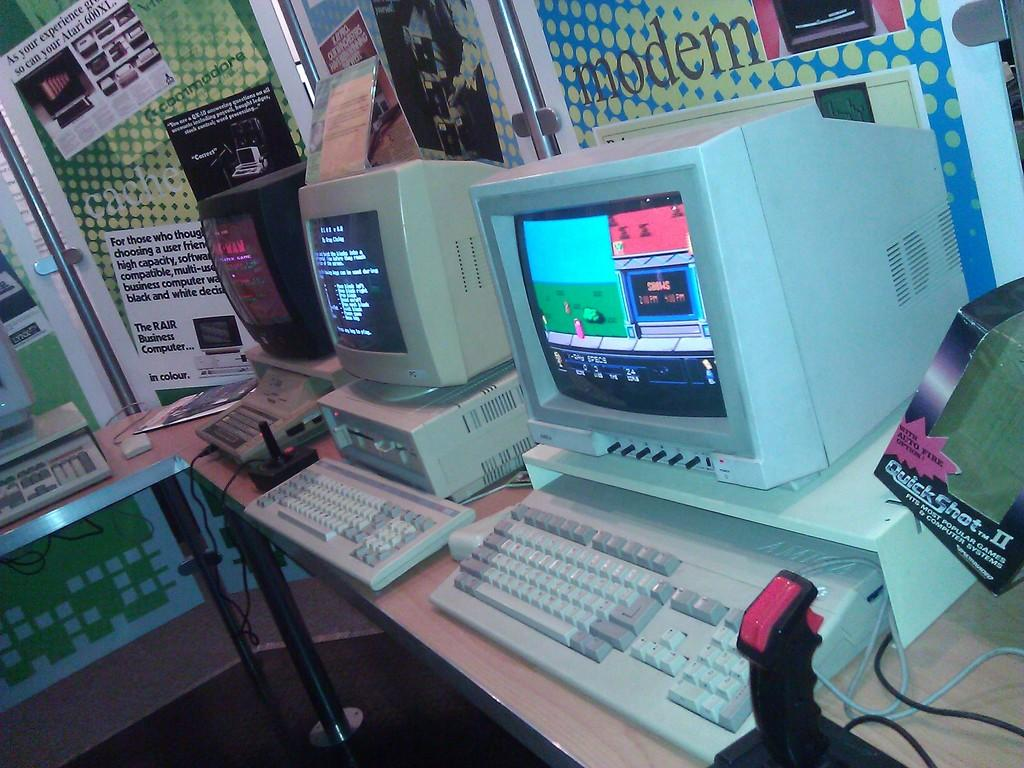<image>
Give a short and clear explanation of the subsequent image. displays of old computers underneath a sign reading MODEM 